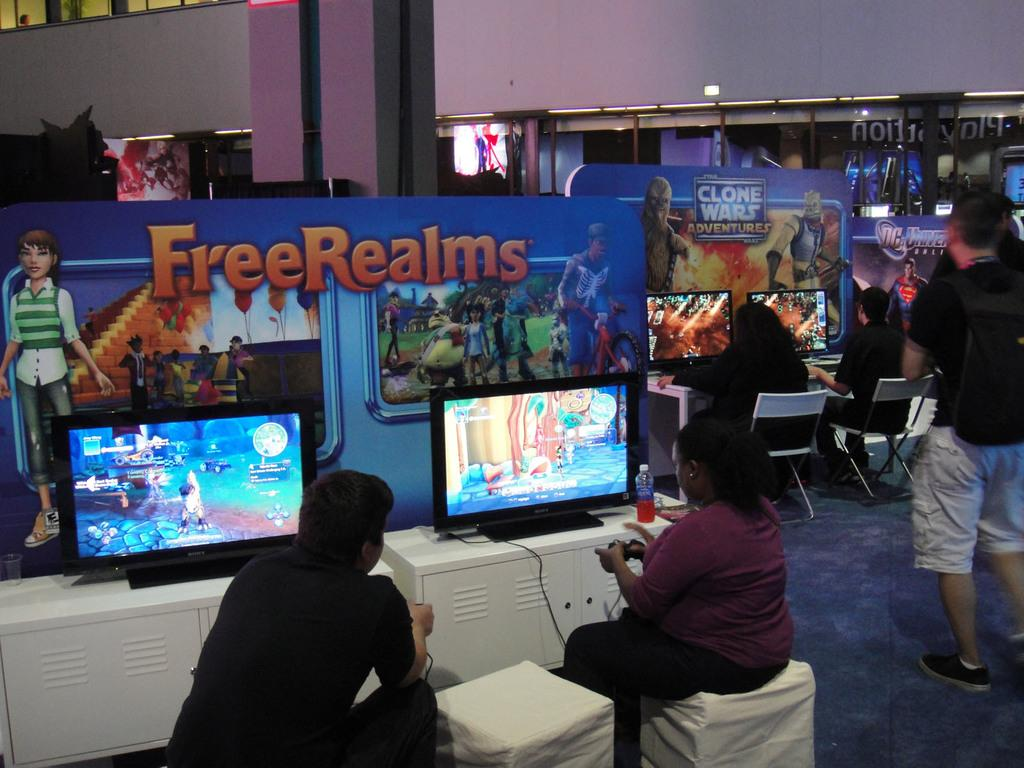How many people are in the image? There is a group of people in the image, but the exact number is not specified. What is the position of the people in the image? The people are on the ground in the image. What type of furniture is present in the image? There are chairs in the image. What type of electronic devices are in the image? There are monitors in the image. What type of visual aids are in the image? There are cartoon boards in the image. What type of structure is visible in the image? There is a wall in the image. Can you describe the unspecified objects in the image? The unspecified objects in the image are not described in the provided facts. What type of muscle can be seen flexing on the wall in the image? There is no muscle visible on the wall in the image. What room is the image taken in? The provided facts do not specify the room or location where the image was taken. 